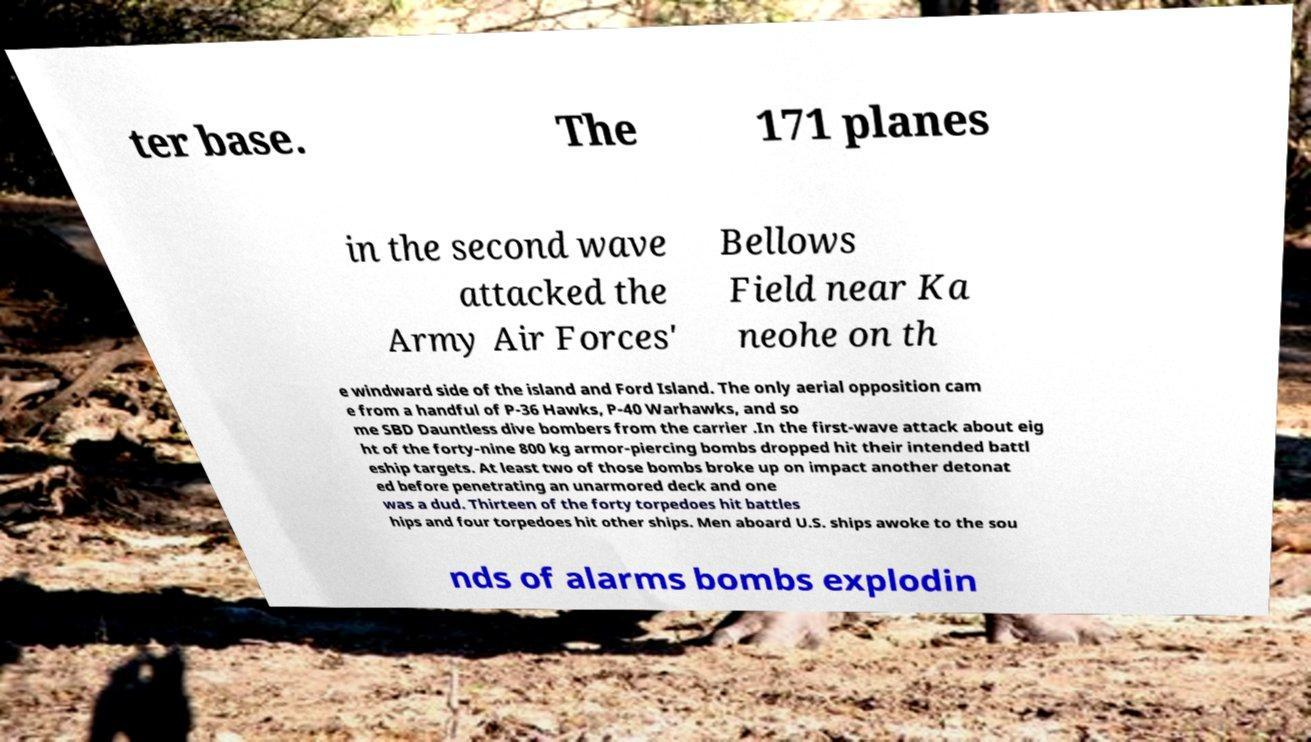There's text embedded in this image that I need extracted. Can you transcribe it verbatim? ter base. The 171 planes in the second wave attacked the Army Air Forces' Bellows Field near Ka neohe on th e windward side of the island and Ford Island. The only aerial opposition cam e from a handful of P-36 Hawks, P-40 Warhawks, and so me SBD Dauntless dive bombers from the carrier .In the first-wave attack about eig ht of the forty-nine 800 kg armor-piercing bombs dropped hit their intended battl eship targets. At least two of those bombs broke up on impact another detonat ed before penetrating an unarmored deck and one was a dud. Thirteen of the forty torpedoes hit battles hips and four torpedoes hit other ships. Men aboard U.S. ships awoke to the sou nds of alarms bombs explodin 